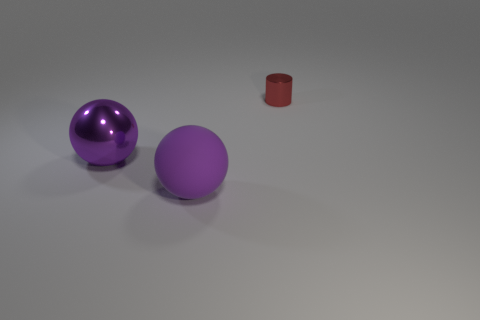Are there any other things that are made of the same material as the small object?
Your answer should be compact. Yes. There is a big object that is left of the large object in front of the sphere that is left of the big rubber ball; what is its shape?
Offer a very short reply. Sphere. What number of other things are there of the same shape as the purple metal thing?
Your answer should be compact. 1. What is the color of the other ball that is the same size as the purple rubber ball?
Make the answer very short. Purple. What number of cylinders are either big red things or tiny red things?
Provide a succinct answer. 1. How many small yellow metal blocks are there?
Your answer should be compact. 0. Is the shape of the purple metallic object the same as the metal object that is to the right of the purple rubber thing?
Provide a short and direct response. No. There is a shiny sphere that is the same color as the rubber sphere; what size is it?
Your response must be concise. Large. What number of objects are metallic spheres or large blue blocks?
Your answer should be very brief. 1. There is a metal thing that is in front of the tiny shiny cylinder right of the large purple matte object; what is its shape?
Keep it short and to the point. Sphere. 